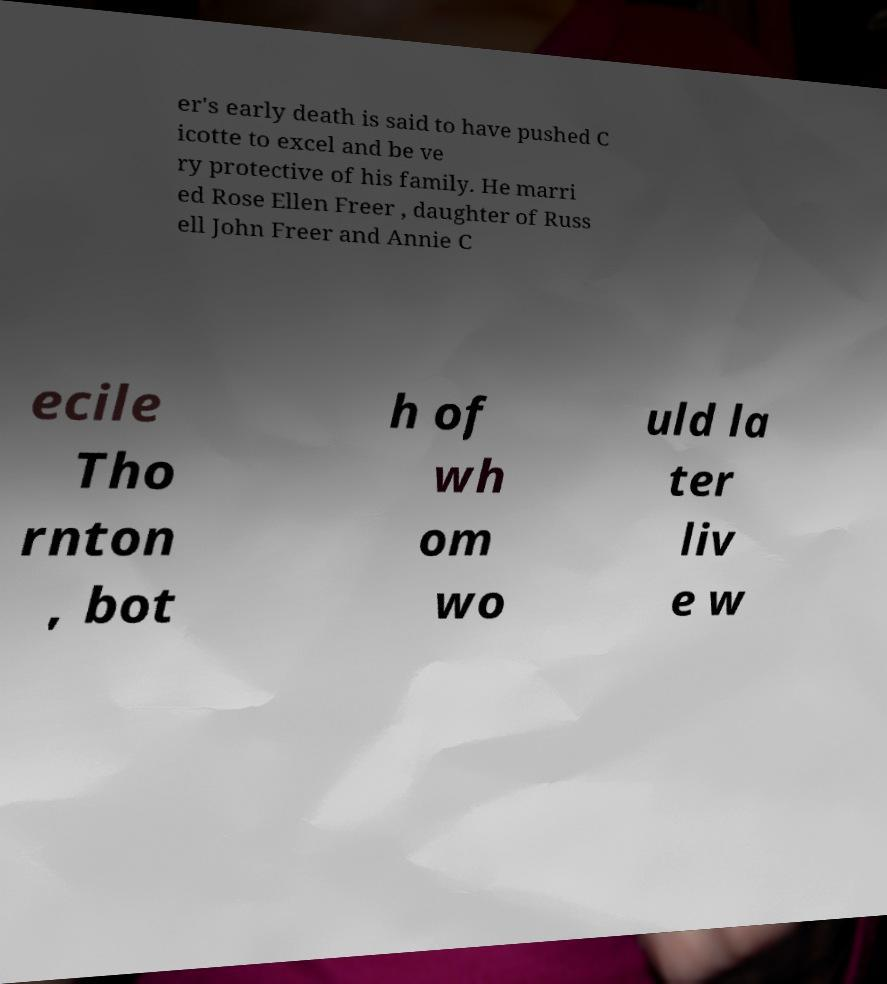What messages or text are displayed in this image? I need them in a readable, typed format. er's early death is said to have pushed C icotte to excel and be ve ry protective of his family. He marri ed Rose Ellen Freer , daughter of Russ ell John Freer and Annie C ecile Tho rnton , bot h of wh om wo uld la ter liv e w 